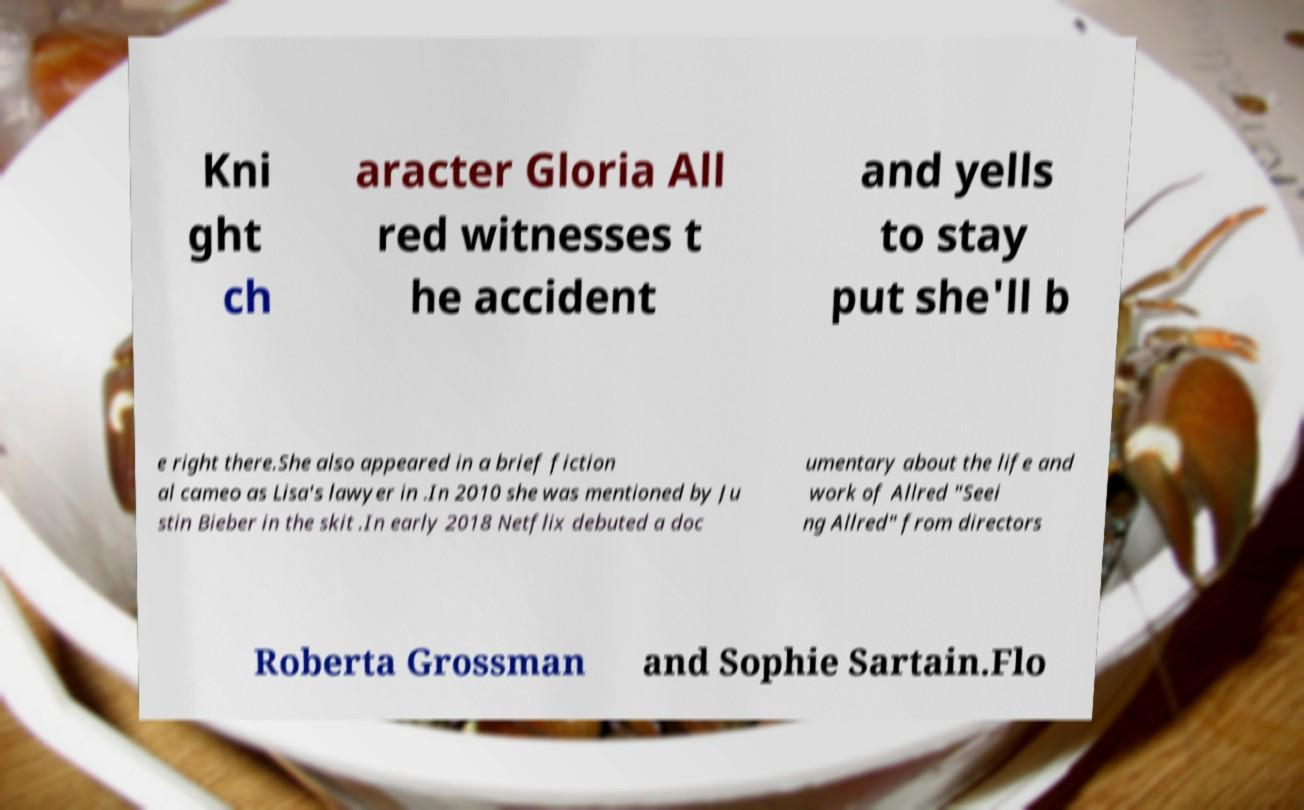Could you assist in decoding the text presented in this image and type it out clearly? Kni ght ch aracter Gloria All red witnesses t he accident and yells to stay put she'll b e right there.She also appeared in a brief fiction al cameo as Lisa's lawyer in .In 2010 she was mentioned by Ju stin Bieber in the skit .In early 2018 Netflix debuted a doc umentary about the life and work of Allred "Seei ng Allred" from directors Roberta Grossman and Sophie Sartain.Flo 